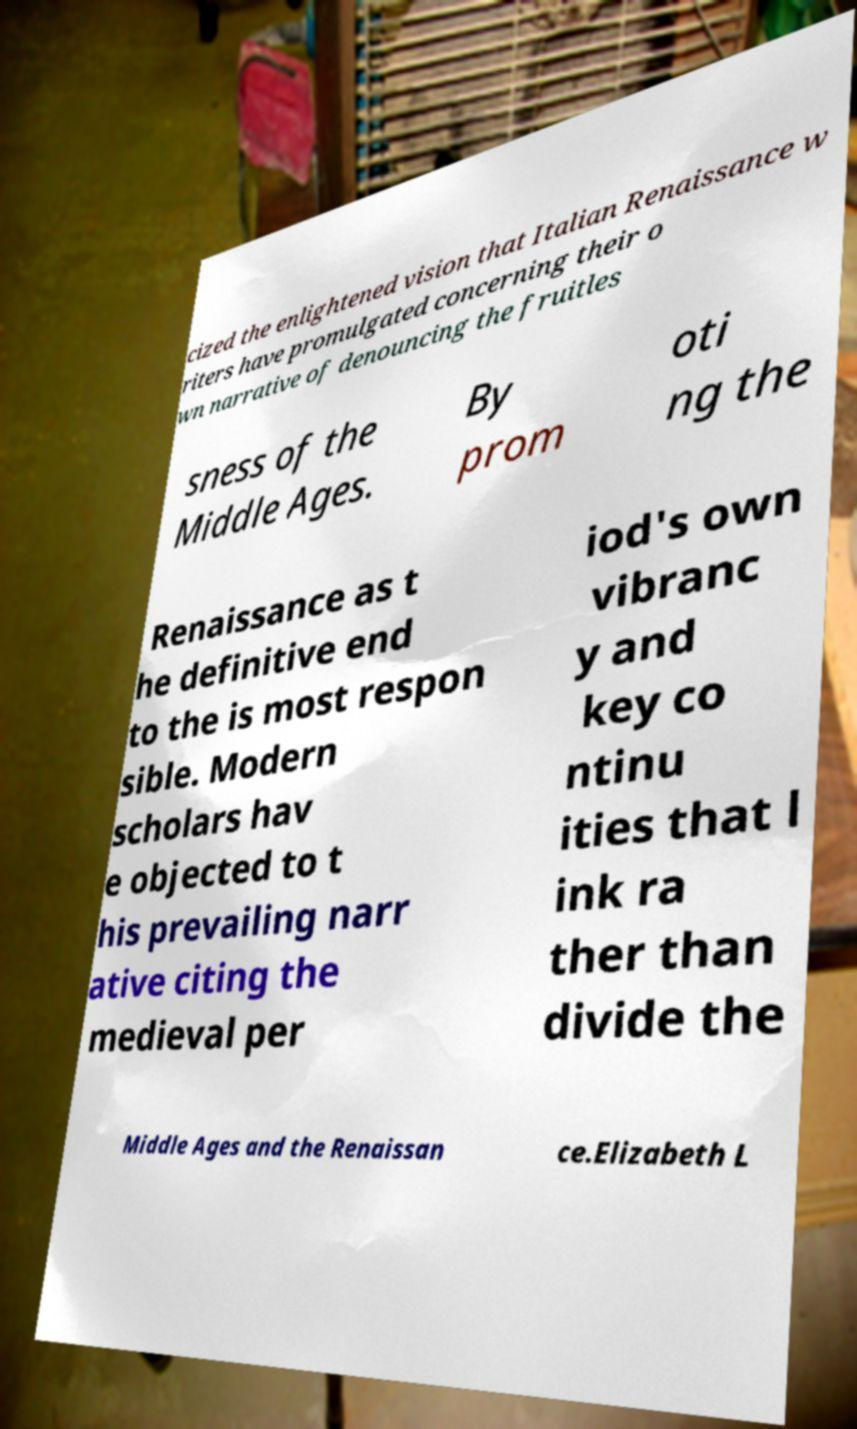I need the written content from this picture converted into text. Can you do that? cized the enlightened vision that Italian Renaissance w riters have promulgated concerning their o wn narrative of denouncing the fruitles sness of the Middle Ages. By prom oti ng the Renaissance as t he definitive end to the is most respon sible. Modern scholars hav e objected to t his prevailing narr ative citing the medieval per iod's own vibranc y and key co ntinu ities that l ink ra ther than divide the Middle Ages and the Renaissan ce.Elizabeth L 